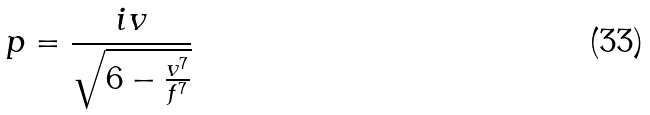<formula> <loc_0><loc_0><loc_500><loc_500>p = \frac { i v } { \sqrt { 6 - \frac { v ^ { 7 } } { f ^ { 7 } } } }</formula> 